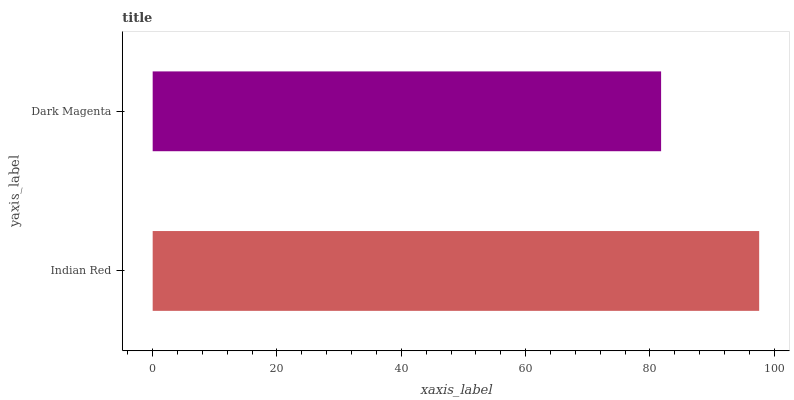Is Dark Magenta the minimum?
Answer yes or no. Yes. Is Indian Red the maximum?
Answer yes or no. Yes. Is Dark Magenta the maximum?
Answer yes or no. No. Is Indian Red greater than Dark Magenta?
Answer yes or no. Yes. Is Dark Magenta less than Indian Red?
Answer yes or no. Yes. Is Dark Magenta greater than Indian Red?
Answer yes or no. No. Is Indian Red less than Dark Magenta?
Answer yes or no. No. Is Indian Red the high median?
Answer yes or no. Yes. Is Dark Magenta the low median?
Answer yes or no. Yes. Is Dark Magenta the high median?
Answer yes or no. No. Is Indian Red the low median?
Answer yes or no. No. 